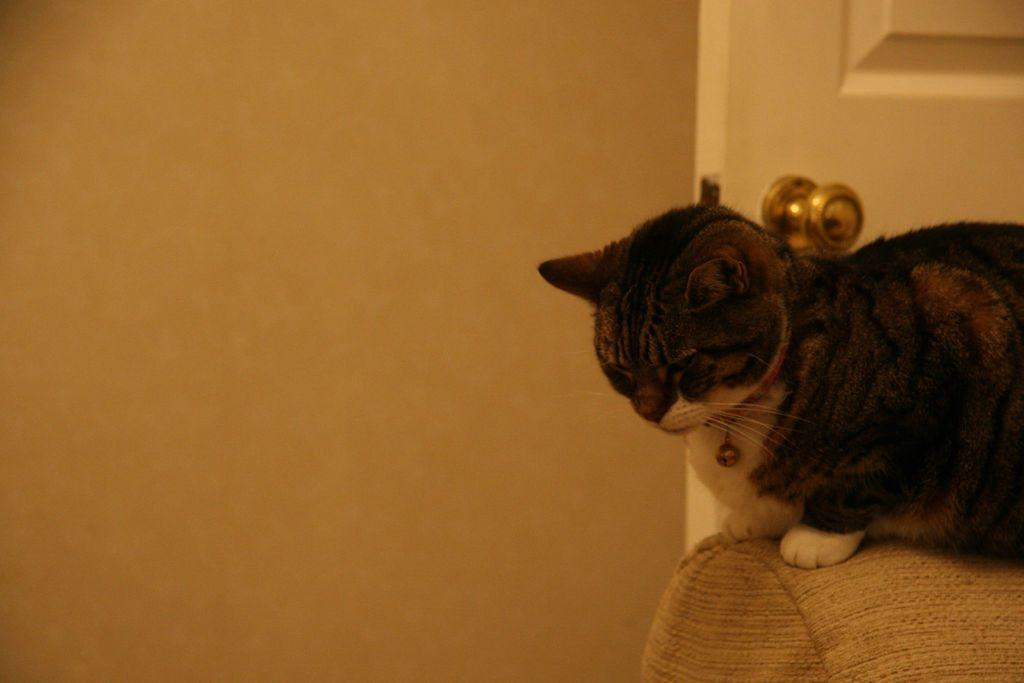What type of animal is in the image? There is a black and white cat in the image. What is the cat sitting or lying on? The cat is on a cloth. What type of apparel is the cat wearing in the image? The cat is not wearing any apparel in the image. What month is depicted on the calendar in the image? There is no calendar present in the image. 